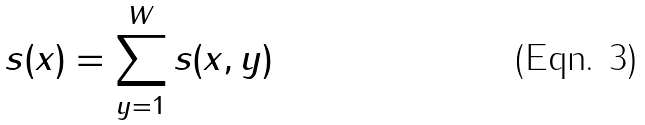Convert formula to latex. <formula><loc_0><loc_0><loc_500><loc_500>s ( x ) = \sum _ { y = 1 } ^ { W } s ( x , y ) \,</formula> 